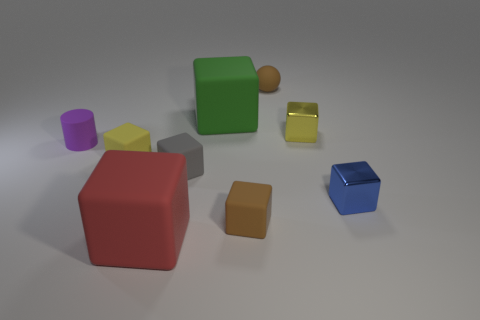Subtract all balls. How many objects are left? 8 Add 1 red blocks. How many objects exist? 10 Subtract all small gray blocks. How many blocks are left? 6 Subtract 1 blue cubes. How many objects are left? 8 Subtract 1 balls. How many balls are left? 0 Subtract all brown blocks. Subtract all green spheres. How many blocks are left? 6 Subtract all green cubes. How many yellow balls are left? 0 Subtract all red metal cylinders. Subtract all yellow blocks. How many objects are left? 7 Add 7 big rubber objects. How many big rubber objects are left? 9 Add 2 yellow metallic things. How many yellow metallic things exist? 3 